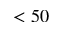Convert formula to latex. <formula><loc_0><loc_0><loc_500><loc_500>< 5 0</formula> 